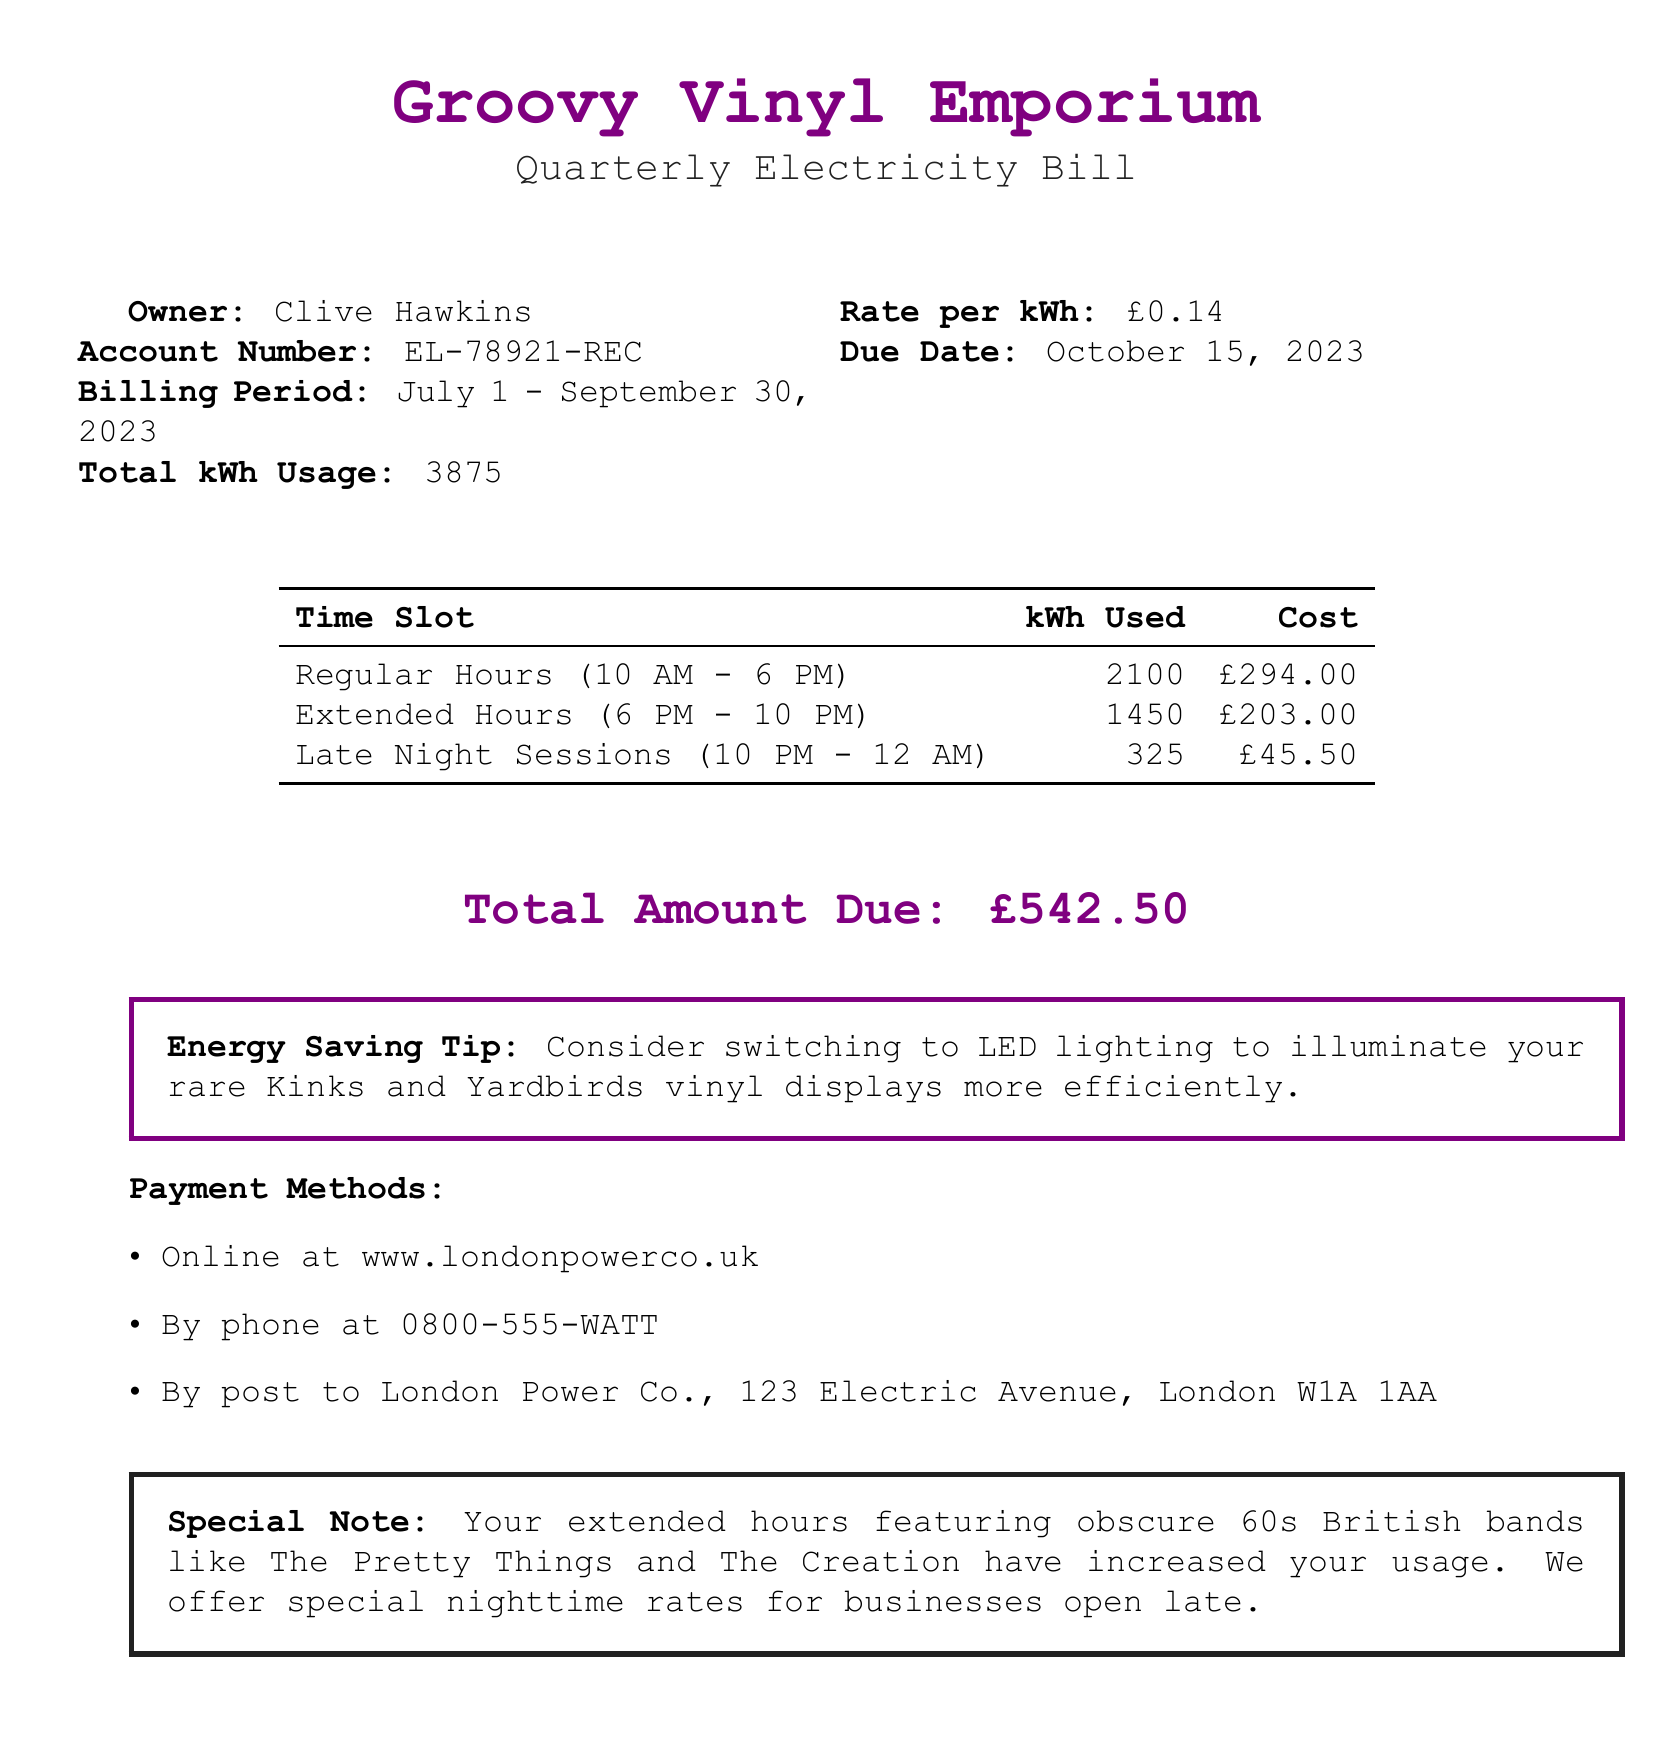What is the account number? The account number is provided in the document as a specific identifier for the bill.
Answer: EL-78921-REC What is the total kWh usage for the billing period? The total kWh usage is a key value reflecting the energy consumed during the billing period.
Answer: 3875 What is the due date for the electricity bill? The due date indicates when the payment must be made according to the document.
Answer: October 15, 2023 How much did the extended hours (6 PM - 10 PM) cost? The cost of the extended hours is explicitly listed in the payment breakdown section of the bill.
Answer: £203.00 What is the total amount due? The total amount due sums up all the costs as listed in the document.
Answer: £542.50 What energy-saving tip is provided? The bill includes a specific suggestion for saving energy related to lighting in the store.
Answer: Consider switching to LED lighting What are the regular business hours mentioned? The regular business hours define the standard operating period of the record store, relevant for understanding usage.
Answer: 10 AM - 6 PM What is the kWh usage during Late Night Sessions (10 PM - 12 AM)? The kWh usage during this time is clearly outlined in the table for usage breakdown.
Answer: 325 How can payments be made? The document lists various methods of payment available to the customer.
Answer: Online, By phone, By post 